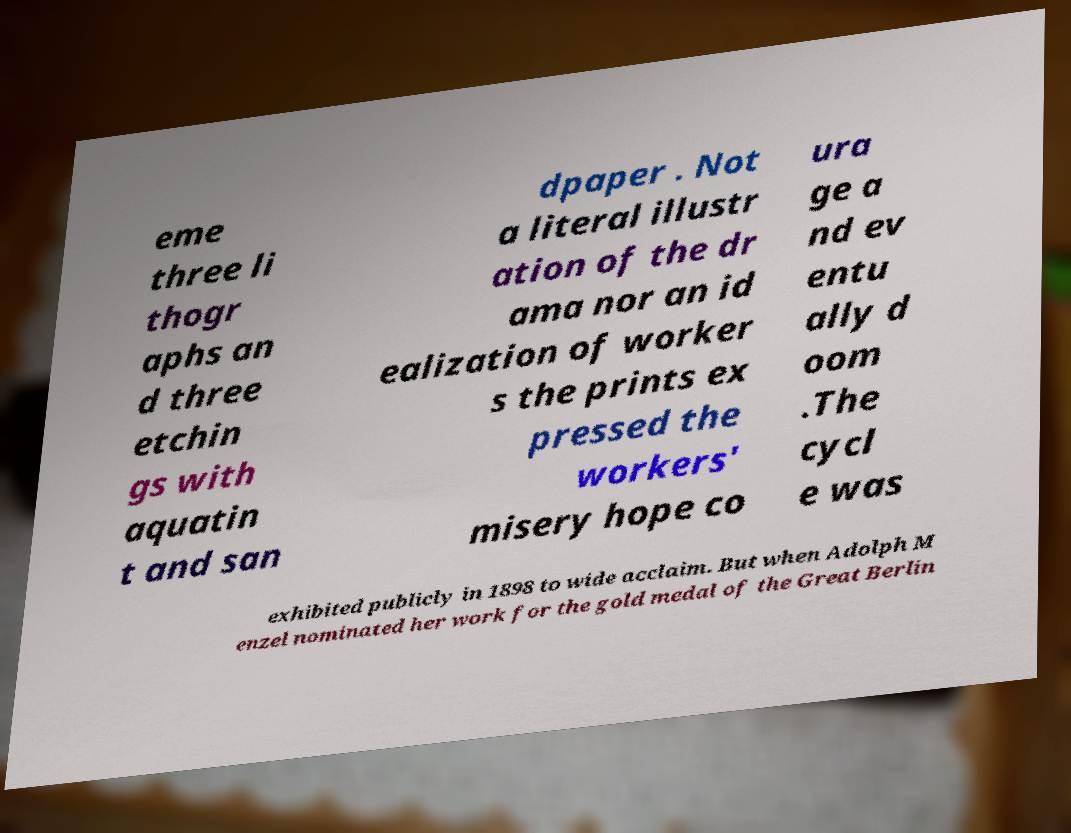Could you extract and type out the text from this image? eme three li thogr aphs an d three etchin gs with aquatin t and san dpaper . Not a literal illustr ation of the dr ama nor an id ealization of worker s the prints ex pressed the workers' misery hope co ura ge a nd ev entu ally d oom .The cycl e was exhibited publicly in 1898 to wide acclaim. But when Adolph M enzel nominated her work for the gold medal of the Great Berlin 